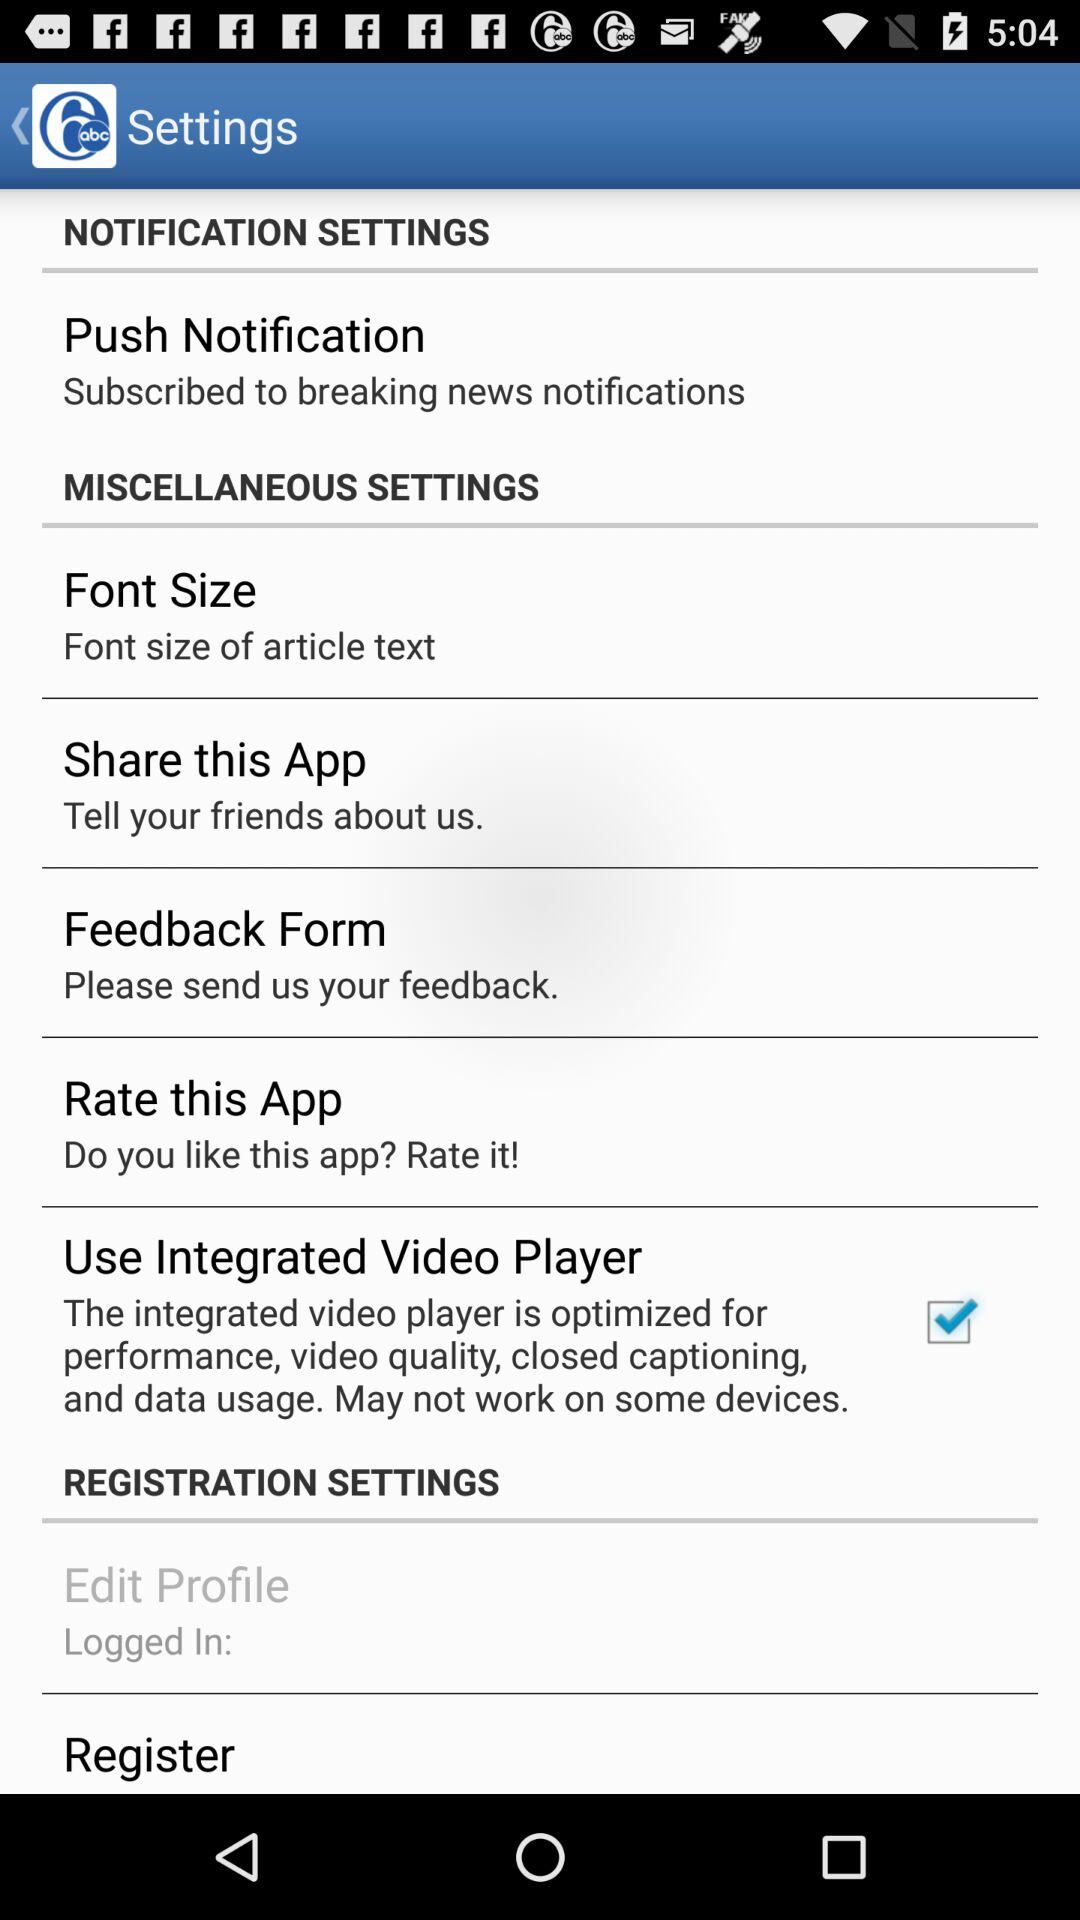What's the status of "Use Integrated Video Player"? The status is "on". 